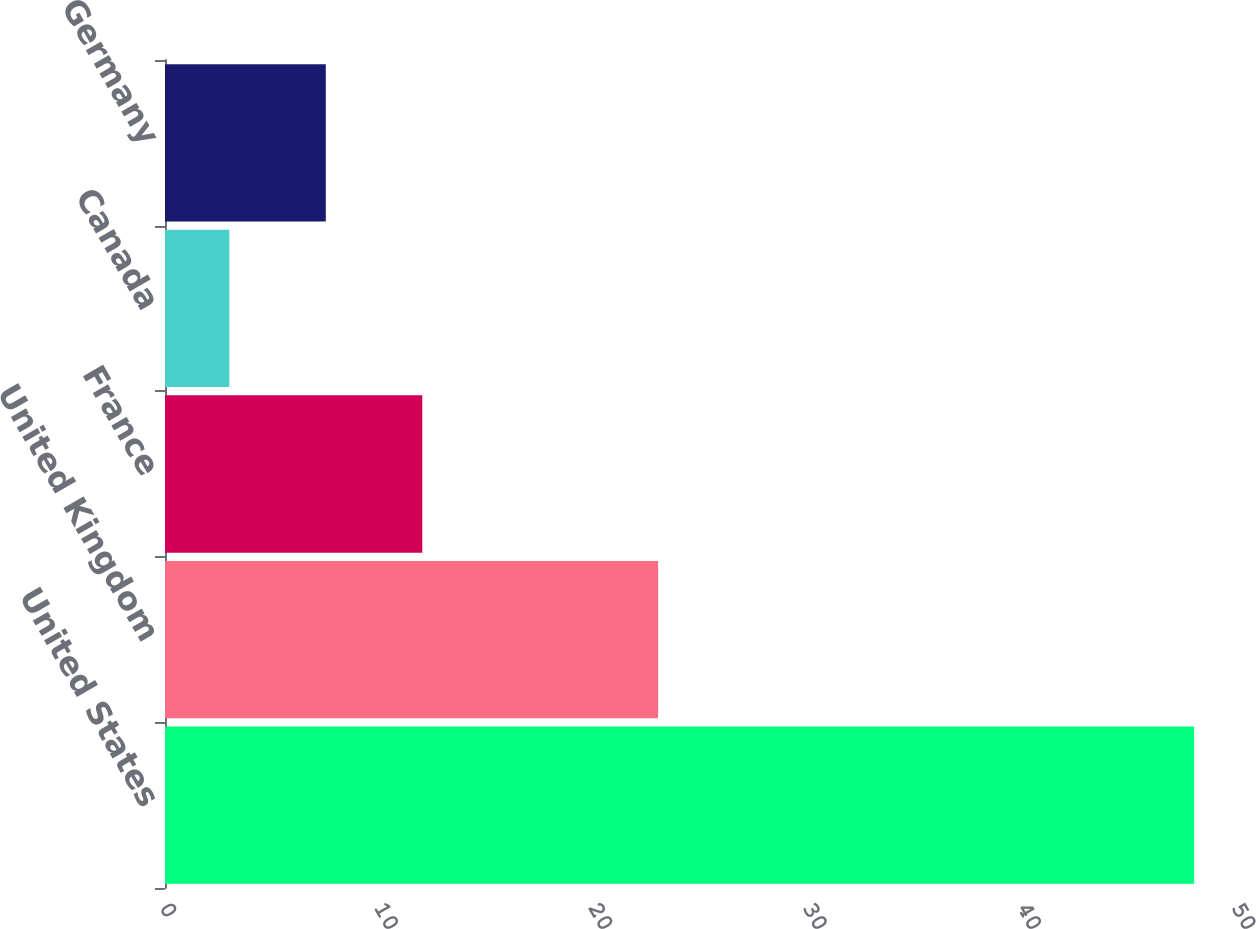Convert chart to OTSL. <chart><loc_0><loc_0><loc_500><loc_500><bar_chart><fcel>United States<fcel>United Kingdom<fcel>France<fcel>Canada<fcel>Germany<nl><fcel>48<fcel>23<fcel>12<fcel>3<fcel>7.5<nl></chart> 